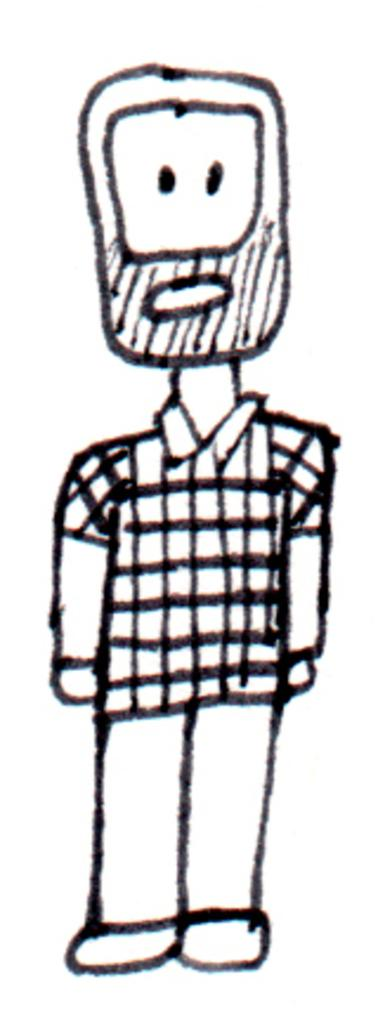What type of image is shown in the picture? The image is a drawing. What is the main subject of the drawing? The drawing depicts a person. How many fowls are present in the drawing? There are no fowls depicted in the drawing; it only features a person. Can you describe the person stretching in the drawing? There is no person stretching in the drawing, as the provided facts do not mention any stretching or movement. 